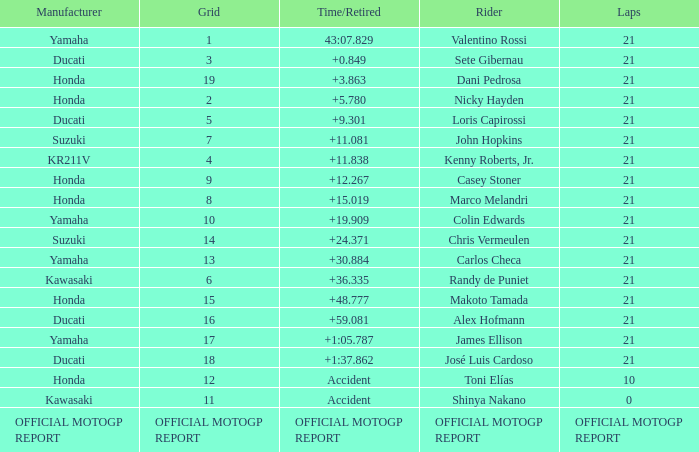What was the amount of laps for the vehicle manufactured by honda with a grid of 9? 21.0. 